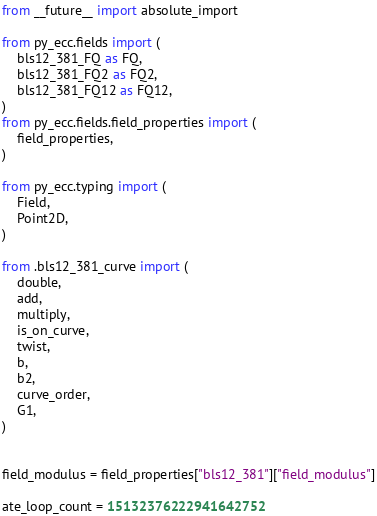<code> <loc_0><loc_0><loc_500><loc_500><_Python_>from __future__ import absolute_import

from py_ecc.fields import (
    bls12_381_FQ as FQ,
    bls12_381_FQ2 as FQ2,
    bls12_381_FQ12 as FQ12,
)
from py_ecc.fields.field_properties import (
    field_properties,
)

from py_ecc.typing import (
    Field,
    Point2D,
)

from .bls12_381_curve import (
    double,
    add,
    multiply,
    is_on_curve,
    twist,
    b,
    b2,
    curve_order,
    G1,
)


field_modulus = field_properties["bls12_381"]["field_modulus"]

ate_loop_count = 15132376222941642752</code> 